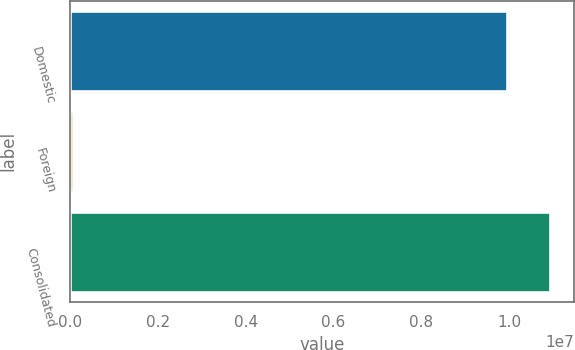<chart> <loc_0><loc_0><loc_500><loc_500><bar_chart><fcel>Domestic<fcel>Foreign<fcel>Consolidated<nl><fcel>9.95023e+06<fcel>71900<fcel>1.09453e+07<nl></chart> 